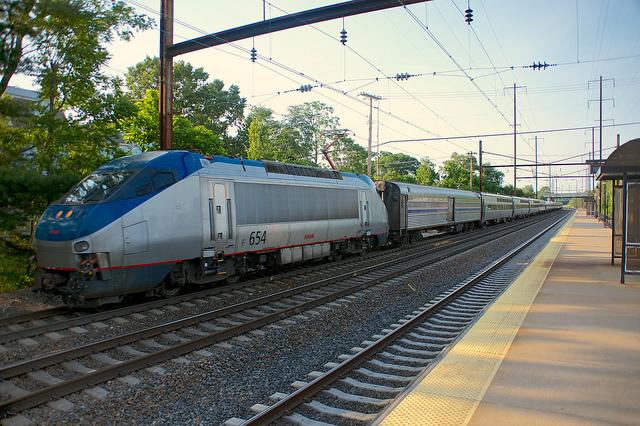What kind of train is it?
Write a very short answer. Passenger. Why is there a yellow line on the loading platforms?
Give a very brief answer. So people don't step on tracks. What numbers are on the train?
Quick response, please. 654. Are people waiting for the train?
Concise answer only. No. How can you get in the train?
Quick response, please. Doors. 